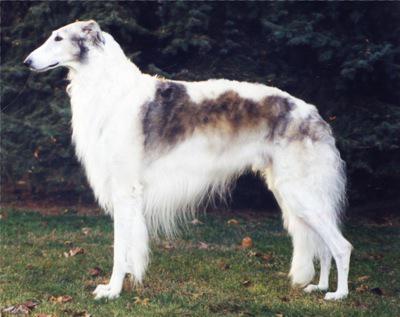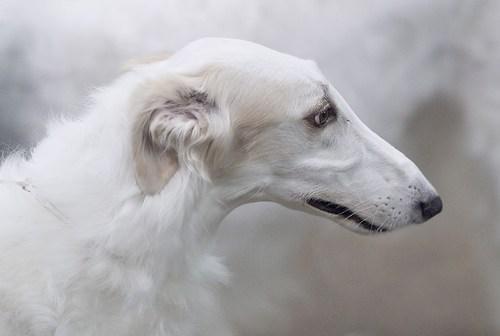The first image is the image on the left, the second image is the image on the right. For the images shown, is this caption "There are two dogs total, facing both left and right." true? Answer yes or no. Yes. The first image is the image on the left, the second image is the image on the right. Evaluate the accuracy of this statement regarding the images: "One dog is facing left and one dog is facing right.". Is it true? Answer yes or no. Yes. 